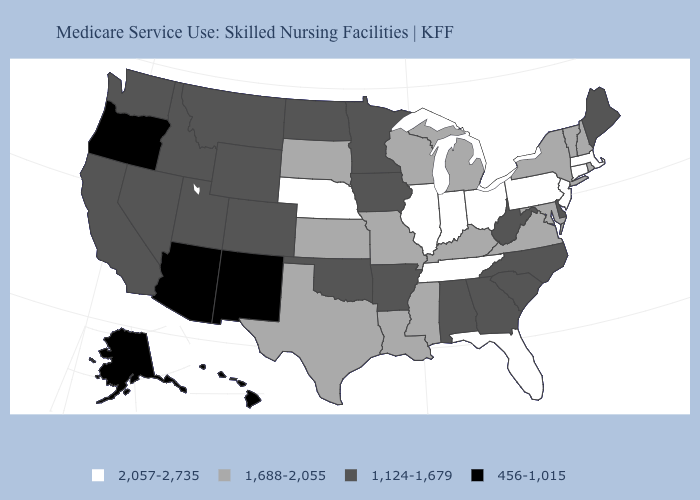Name the states that have a value in the range 456-1,015?
Concise answer only. Alaska, Arizona, Hawaii, New Mexico, Oregon. What is the highest value in states that border Oregon?
Short answer required. 1,124-1,679. Name the states that have a value in the range 1,124-1,679?
Answer briefly. Alabama, Arkansas, California, Colorado, Delaware, Georgia, Idaho, Iowa, Maine, Minnesota, Montana, Nevada, North Carolina, North Dakota, Oklahoma, South Carolina, Utah, Washington, West Virginia, Wyoming. Among the states that border Wyoming , does Idaho have the lowest value?
Answer briefly. Yes. What is the value of Missouri?
Give a very brief answer. 1,688-2,055. How many symbols are there in the legend?
Concise answer only. 4. Which states have the lowest value in the South?
Give a very brief answer. Alabama, Arkansas, Delaware, Georgia, North Carolina, Oklahoma, South Carolina, West Virginia. Does the first symbol in the legend represent the smallest category?
Concise answer only. No. What is the value of Alaska?
Short answer required. 456-1,015. What is the value of Arkansas?
Write a very short answer. 1,124-1,679. What is the highest value in states that border Florida?
Answer briefly. 1,124-1,679. Name the states that have a value in the range 1,124-1,679?
Keep it brief. Alabama, Arkansas, California, Colorado, Delaware, Georgia, Idaho, Iowa, Maine, Minnesota, Montana, Nevada, North Carolina, North Dakota, Oklahoma, South Carolina, Utah, Washington, West Virginia, Wyoming. What is the lowest value in states that border Virginia?
Be succinct. 1,124-1,679. What is the lowest value in the South?
Concise answer only. 1,124-1,679. Does Ohio have the highest value in the MidWest?
Short answer required. Yes. 